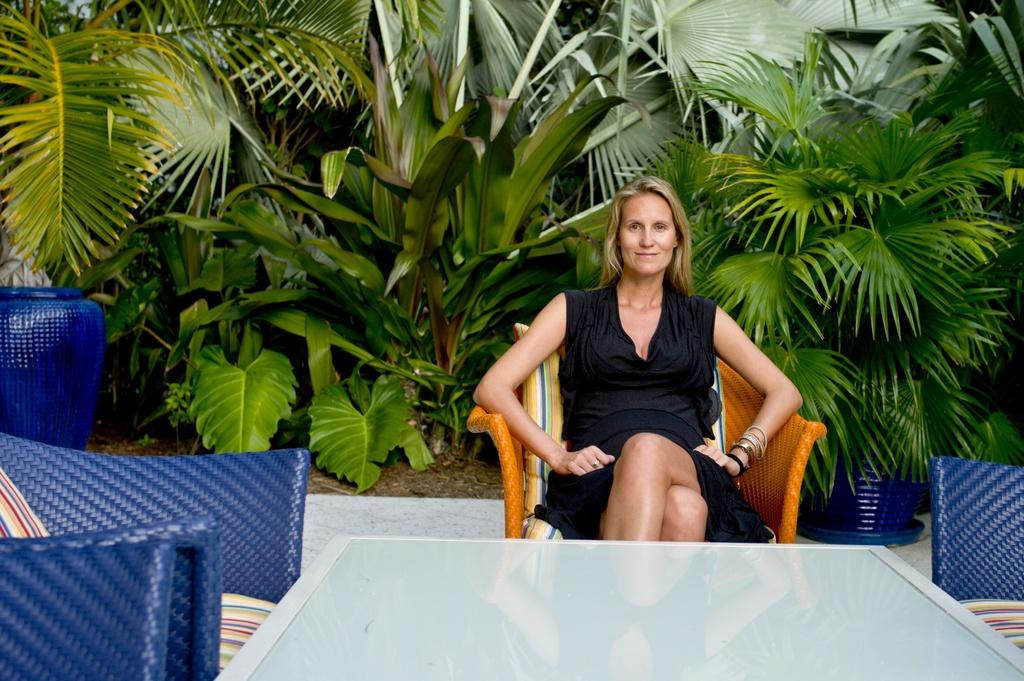What is the woman in the image doing? The woman is sitting on a chair in the image. Can you describe the setting in the image? There are other chairs in the background of the image, and there is a plant visible in the background. What type of curtain can be seen hanging from the window in the image? There is no window or curtain present in the image. Is the woman holding a gun in the image? There is no gun present in the image. 